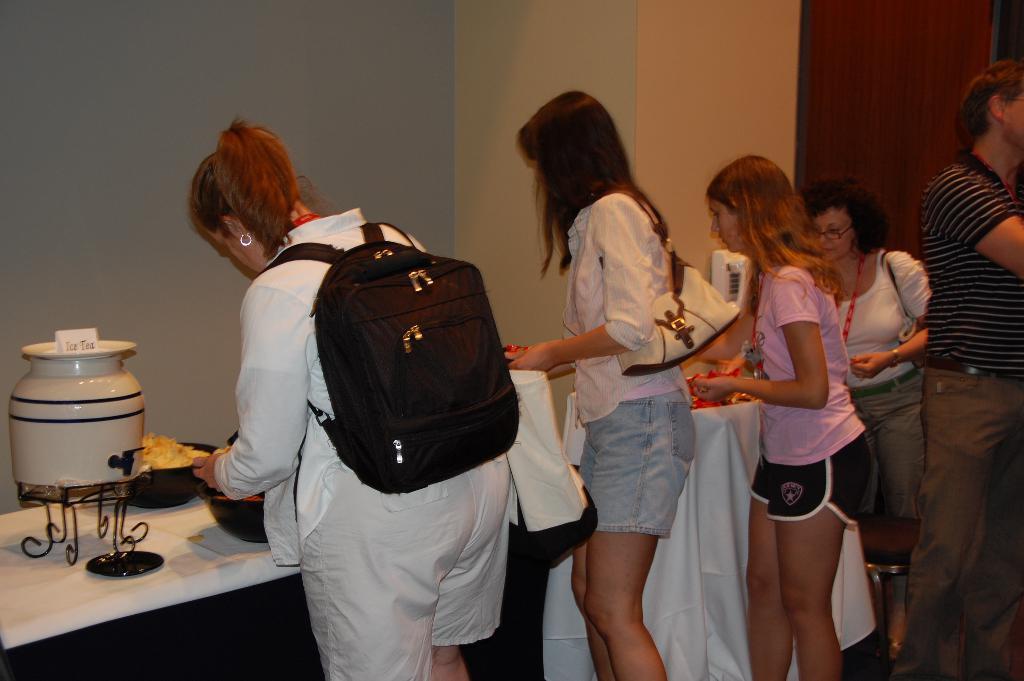Could you give a brief overview of what you see in this image? In the image there are few women standing in front of table with food bowls on it with a jar, in the back there is wall, on the right side there is a man standing. 